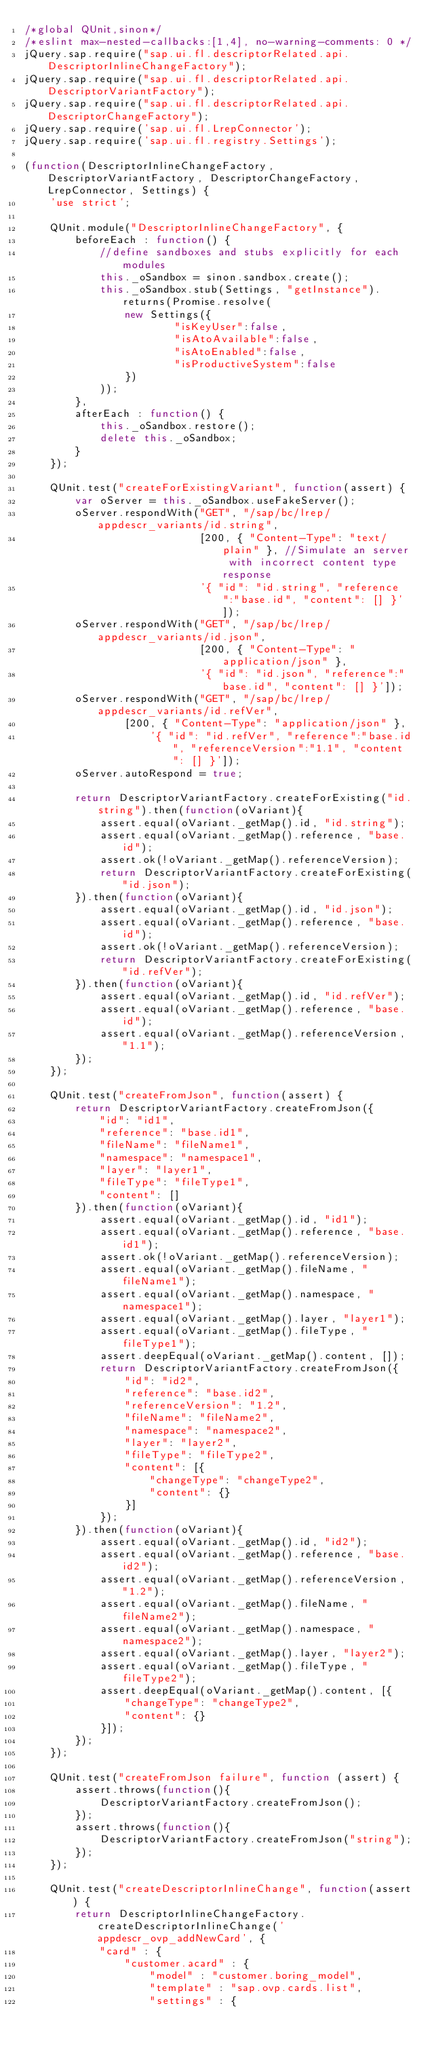<code> <loc_0><loc_0><loc_500><loc_500><_JavaScript_>/*global QUnit,sinon*/
/*eslint max-nested-callbacks:[1,4], no-warning-comments: 0 */
jQuery.sap.require("sap.ui.fl.descriptorRelated.api.DescriptorInlineChangeFactory");
jQuery.sap.require("sap.ui.fl.descriptorRelated.api.DescriptorVariantFactory");
jQuery.sap.require("sap.ui.fl.descriptorRelated.api.DescriptorChangeFactory");
jQuery.sap.require('sap.ui.fl.LrepConnector');
jQuery.sap.require('sap.ui.fl.registry.Settings');

(function(DescriptorInlineChangeFactory, DescriptorVariantFactory, DescriptorChangeFactory, LrepConnector, Settings) {
	'use strict';

	QUnit.module("DescriptorInlineChangeFactory", {
		beforeEach : function() {
			//define sandboxes and stubs explicitly for each modules
			this._oSandbox = sinon.sandbox.create();
			this._oSandbox.stub(Settings, "getInstance").returns(Promise.resolve(
				new Settings({
						"isKeyUser":false,
						"isAtoAvailable":false,
						"isAtoEnabled":false,
						"isProductiveSystem":false
				})
			));
		},
		afterEach : function() {
			this._oSandbox.restore();
			delete this._oSandbox;
		}
	});

	QUnit.test("createForExistingVariant", function(assert) {
		var oServer = this._oSandbox.useFakeServer();
		oServer.respondWith("GET", "/sap/bc/lrep/appdescr_variants/id.string",
							[200, { "Content-Type": "text/plain" }, //Simulate an server with incorrect content type response
							'{ "id": "id.string", "reference":"base.id", "content": [] }']);
		oServer.respondWith("GET", "/sap/bc/lrep/appdescr_variants/id.json",
							[200, { "Content-Type": "application/json" },
							'{ "id": "id.json", "reference":"base.id", "content": [] }']);
		oServer.respondWith("GET", "/sap/bc/lrep/appdescr_variants/id.refVer",
				[200, { "Content-Type": "application/json" },
					'{ "id": "id.refVer", "reference":"base.id", "referenceVersion":"1.1", "content": [] }']);
		oServer.autoRespond = true;

		return DescriptorVariantFactory.createForExisting("id.string").then(function(oVariant){
			assert.equal(oVariant._getMap().id, "id.string");
			assert.equal(oVariant._getMap().reference, "base.id");
			assert.ok(!oVariant._getMap().referenceVersion);
			return DescriptorVariantFactory.createForExisting("id.json");
		}).then(function(oVariant){
			assert.equal(oVariant._getMap().id, "id.json");
			assert.equal(oVariant._getMap().reference, "base.id");
			assert.ok(!oVariant._getMap().referenceVersion);
			return DescriptorVariantFactory.createForExisting("id.refVer");
		}).then(function(oVariant){
			assert.equal(oVariant._getMap().id, "id.refVer");
			assert.equal(oVariant._getMap().reference, "base.id");
			assert.equal(oVariant._getMap().referenceVersion, "1.1");
		});
	});

	QUnit.test("createFromJson", function(assert) {
		return DescriptorVariantFactory.createFromJson({
			"id": "id1",
			"reference": "base.id1",
			"fileName": "fileName1",
			"namespace": "namespace1",
			"layer": "layer1",
			"fileType": "fileType1",
			"content": []
		}).then(function(oVariant){
			assert.equal(oVariant._getMap().id, "id1");
			assert.equal(oVariant._getMap().reference, "base.id1");
			assert.ok(!oVariant._getMap().referenceVersion);
			assert.equal(oVariant._getMap().fileName, "fileName1");
			assert.equal(oVariant._getMap().namespace, "namespace1");
			assert.equal(oVariant._getMap().layer, "layer1");
			assert.equal(oVariant._getMap().fileType, "fileType1");
			assert.deepEqual(oVariant._getMap().content, []);
			return DescriptorVariantFactory.createFromJson({
				"id": "id2",
				"reference": "base.id2",
				"referenceVersion": "1.2",
				"fileName": "fileName2",
				"namespace": "namespace2",
				"layer": "layer2",
				"fileType": "fileType2",
				"content": [{
					"changeType": "changeType2",
					"content": {}
				}]
			});
		}).then(function(oVariant){
			assert.equal(oVariant._getMap().id, "id2");
			assert.equal(oVariant._getMap().reference, "base.id2");
			assert.equal(oVariant._getMap().referenceVersion, "1.2");
			assert.equal(oVariant._getMap().fileName, "fileName2");
			assert.equal(oVariant._getMap().namespace, "namespace2");
			assert.equal(oVariant._getMap().layer, "layer2");
			assert.equal(oVariant._getMap().fileType, "fileType2");
			assert.deepEqual(oVariant._getMap().content, [{
				"changeType": "changeType2",
				"content": {}
			}]);
		});
	});

	QUnit.test("createFromJson failure", function (assert) {
		assert.throws(function(){
			DescriptorVariantFactory.createFromJson();
		});
		assert.throws(function(){
			DescriptorVariantFactory.createFromJson("string");
		});
	});

	QUnit.test("createDescriptorInlineChange", function(assert) {
		return DescriptorInlineChangeFactory.createDescriptorInlineChange('appdescr_ovp_addNewCard', {
			"card" : {
				"customer.acard" : {
					"model" : "customer.boring_model",
					"template" : "sap.ovp.cards.list",
					"settings" : {</code> 